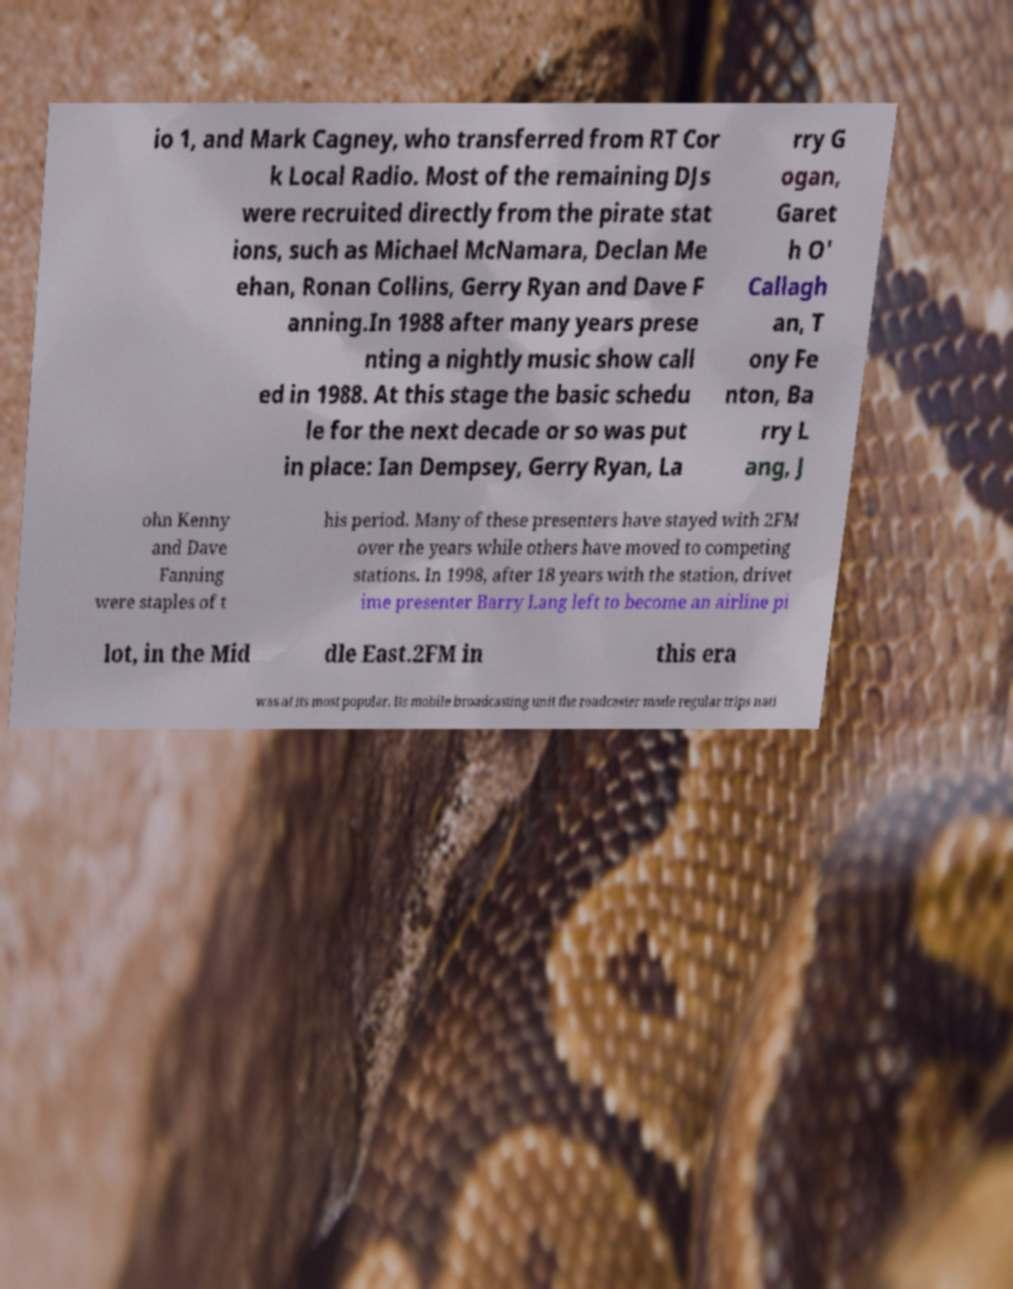For documentation purposes, I need the text within this image transcribed. Could you provide that? io 1, and Mark Cagney, who transferred from RT Cor k Local Radio. Most of the remaining DJs were recruited directly from the pirate stat ions, such as Michael McNamara, Declan Me ehan, Ronan Collins, Gerry Ryan and Dave F anning.In 1988 after many years prese nting a nightly music show call ed in 1988. At this stage the basic schedu le for the next decade or so was put in place: Ian Dempsey, Gerry Ryan, La rry G ogan, Garet h O' Callagh an, T ony Fe nton, Ba rry L ang, J ohn Kenny and Dave Fanning were staples of t his period. Many of these presenters have stayed with 2FM over the years while others have moved to competing stations. In 1998, after 18 years with the station, drivet ime presenter Barry Lang left to become an airline pi lot, in the Mid dle East.2FM in this era was at its most popular. Its mobile broadcasting unit the roadcaster made regular trips nati 